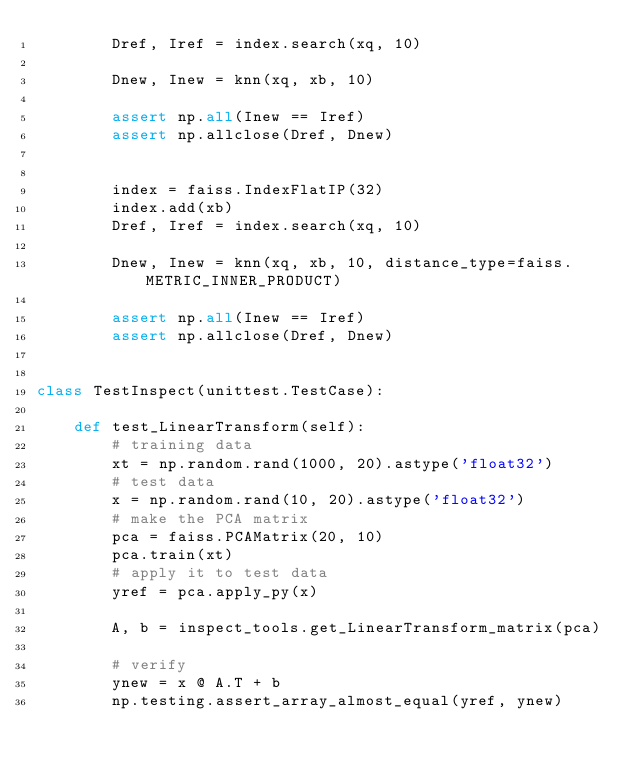Convert code to text. <code><loc_0><loc_0><loc_500><loc_500><_Python_>        Dref, Iref = index.search(xq, 10)

        Dnew, Inew = knn(xq, xb, 10)

        assert np.all(Inew == Iref)
        assert np.allclose(Dref, Dnew)


        index = faiss.IndexFlatIP(32)
        index.add(xb)
        Dref, Iref = index.search(xq, 10)

        Dnew, Inew = knn(xq, xb, 10, distance_type=faiss.METRIC_INNER_PRODUCT)

        assert np.all(Inew == Iref)
        assert np.allclose(Dref, Dnew)


class TestInspect(unittest.TestCase):

    def test_LinearTransform(self):
        # training data
        xt = np.random.rand(1000, 20).astype('float32')
        # test data
        x = np.random.rand(10, 20).astype('float32')
        # make the PCA matrix
        pca = faiss.PCAMatrix(20, 10)
        pca.train(xt)
        # apply it to test data
        yref = pca.apply_py(x)

        A, b = inspect_tools.get_LinearTransform_matrix(pca)

        # verify
        ynew = x @ A.T + b
        np.testing.assert_array_almost_equal(yref, ynew)
</code> 